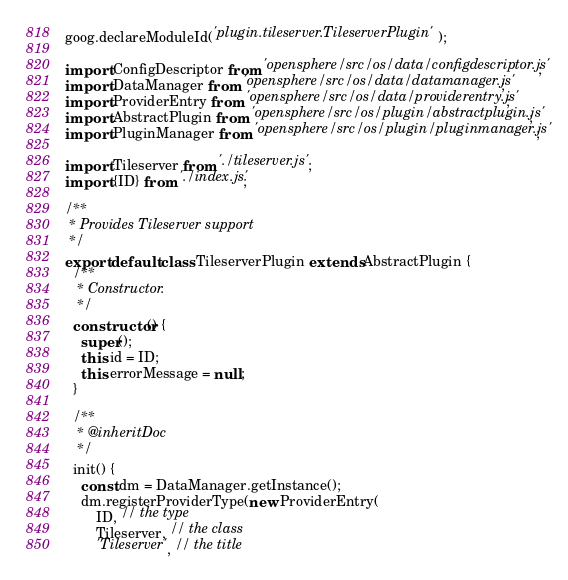<code> <loc_0><loc_0><loc_500><loc_500><_JavaScript_>goog.declareModuleId('plugin.tileserver.TileserverPlugin');

import ConfigDescriptor from 'opensphere/src/os/data/configdescriptor.js';
import DataManager from 'opensphere/src/os/data/datamanager.js';
import ProviderEntry from 'opensphere/src/os/data/providerentry.js';
import AbstractPlugin from 'opensphere/src/os/plugin/abstractplugin.js';
import PluginManager from 'opensphere/src/os/plugin/pluginmanager.js';

import Tileserver from './tileserver.js';
import {ID} from './index.js';

/**
 * Provides Tileserver support
 */
export default class TileserverPlugin extends AbstractPlugin {
  /**
   * Constructor.
   */
  constructor() {
    super();
    this.id = ID;
    this.errorMessage = null;
  }

  /**
   * @inheritDoc
   */
  init() {
    const dm = DataManager.getInstance();
    dm.registerProviderType(new ProviderEntry(
        ID, // the type
        Tileserver, // the class
        'Tileserver', // the title</code> 